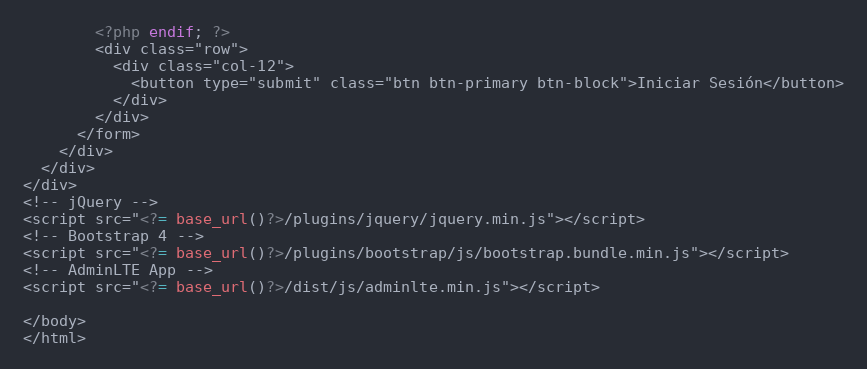<code> <loc_0><loc_0><loc_500><loc_500><_PHP_>        <?php endif; ?>
        <div class="row">
          <div class="col-12">
            <button type="submit" class="btn btn-primary btn-block">Iniciar Sesión</button>
          </div>
        </div>
      </form>
    </div>
  </div>
</div>
<!-- jQuery -->
<script src="<?= base_url()?>/plugins/jquery/jquery.min.js"></script>
<!-- Bootstrap 4 -->
<script src="<?= base_url()?>/plugins/bootstrap/js/bootstrap.bundle.min.js"></script>
<!-- AdminLTE App -->
<script src="<?= base_url()?>/dist/js/adminlte.min.js"></script>

</body>
</html>
</code> 